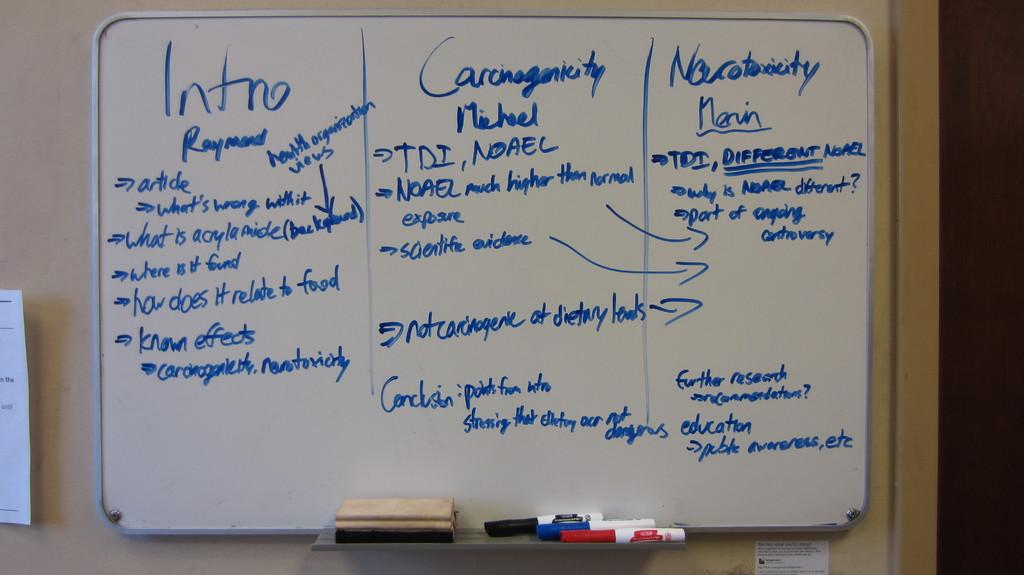<image>
Summarize the visual content of the image. A white board with blue writing that says Intro as a title to a section. 